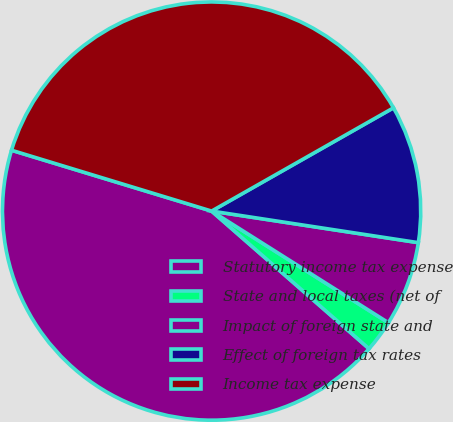<chart> <loc_0><loc_0><loc_500><loc_500><pie_chart><fcel>Statutory income tax expense<fcel>State and local taxes (net of<fcel>Impact of foreign state and<fcel>Effect of foreign tax rates<fcel>Income tax expense<nl><fcel>43.26%<fcel>2.47%<fcel>6.55%<fcel>10.63%<fcel>37.08%<nl></chart> 